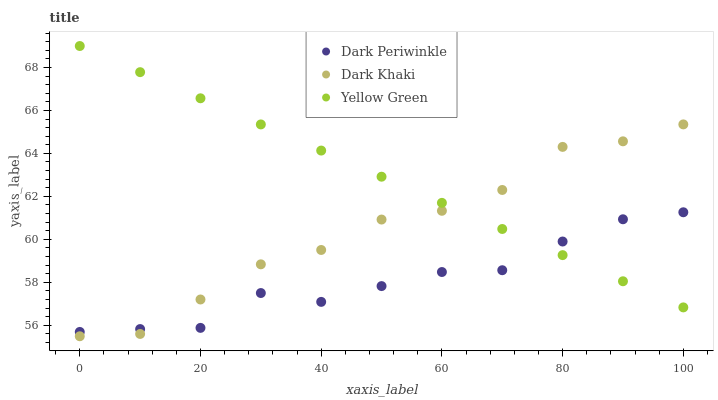Does Dark Periwinkle have the minimum area under the curve?
Answer yes or no. Yes. Does Yellow Green have the maximum area under the curve?
Answer yes or no. Yes. Does Yellow Green have the minimum area under the curve?
Answer yes or no. No. Does Dark Periwinkle have the maximum area under the curve?
Answer yes or no. No. Is Yellow Green the smoothest?
Answer yes or no. Yes. Is Dark Khaki the roughest?
Answer yes or no. Yes. Is Dark Periwinkle the smoothest?
Answer yes or no. No. Is Dark Periwinkle the roughest?
Answer yes or no. No. Does Dark Khaki have the lowest value?
Answer yes or no. Yes. Does Dark Periwinkle have the lowest value?
Answer yes or no. No. Does Yellow Green have the highest value?
Answer yes or no. Yes. Does Dark Periwinkle have the highest value?
Answer yes or no. No. Does Dark Periwinkle intersect Dark Khaki?
Answer yes or no. Yes. Is Dark Periwinkle less than Dark Khaki?
Answer yes or no. No. Is Dark Periwinkle greater than Dark Khaki?
Answer yes or no. No. 